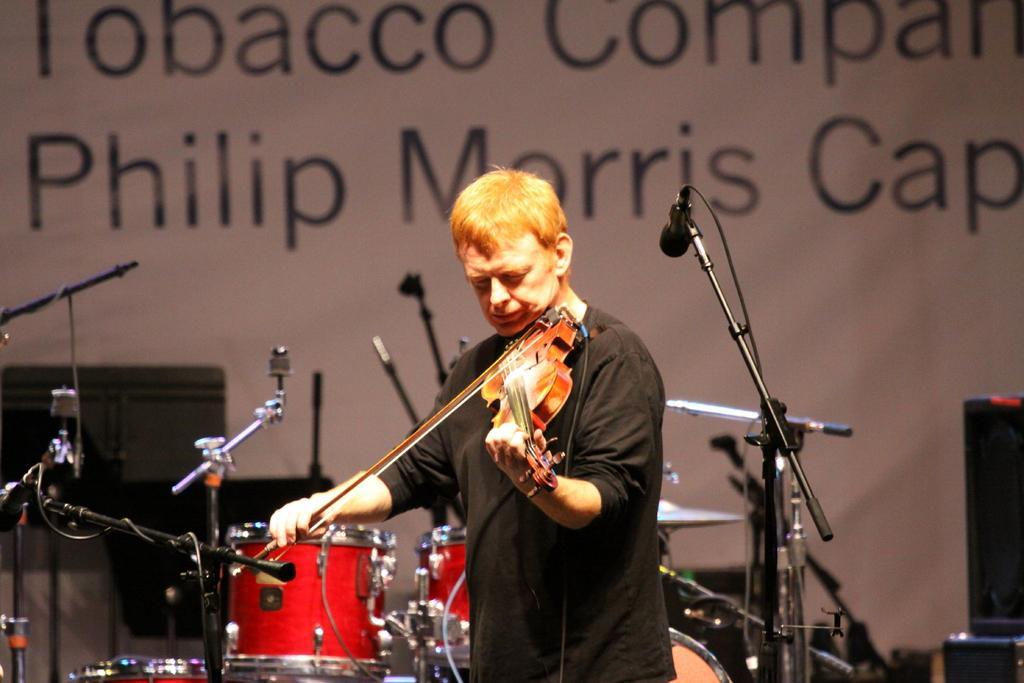Can you describe this image briefly? In this picture we can see man standing playing violin and in front of him there are mics and mic stands and at back of him we can see drums and in background we can see banners, speakers. 